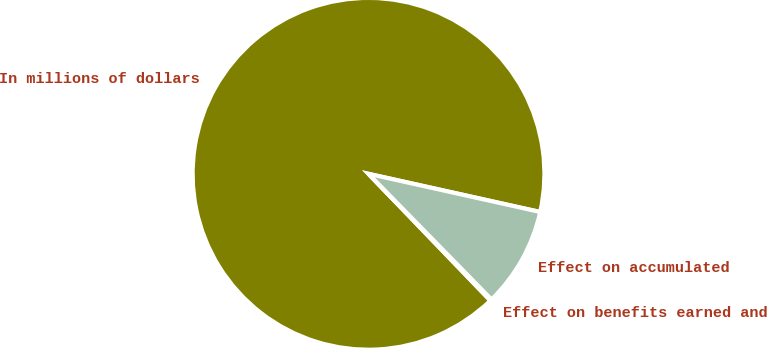<chart> <loc_0><loc_0><loc_500><loc_500><pie_chart><fcel>In millions of dollars<fcel>Effect on benefits earned and<fcel>Effect on accumulated<nl><fcel>90.68%<fcel>0.14%<fcel>9.19%<nl></chart> 